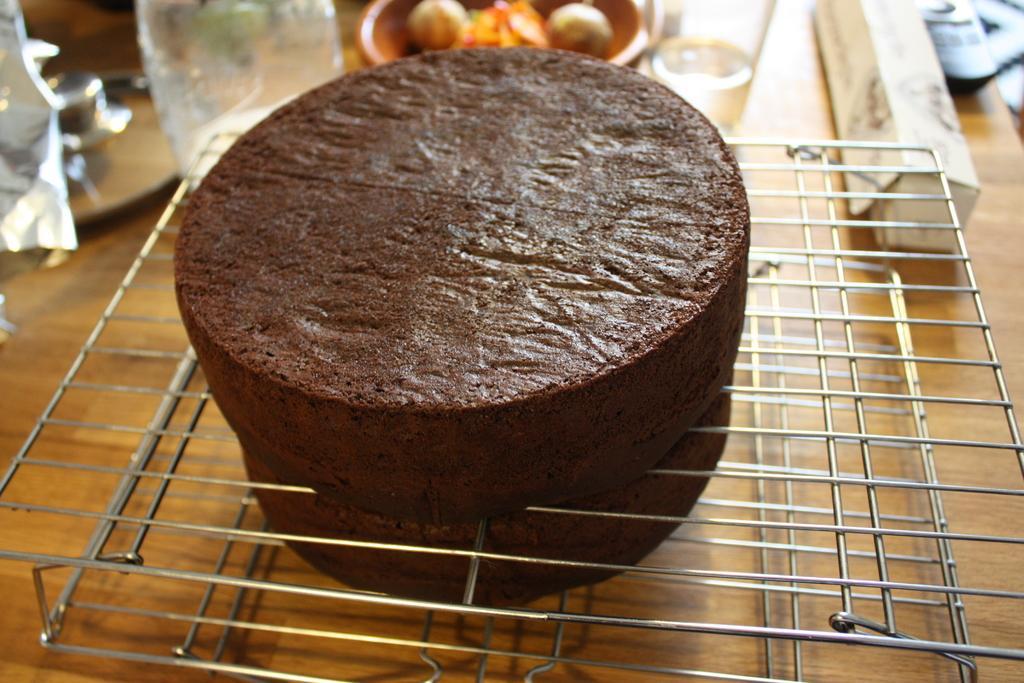Could you give a brief overview of what you see in this image? In this image in the center there is a cake and at the bottom, there is some object. And in the background there are some glasses, bowl, bottle, and some other objects. At the bottom it looks like a wooden table. 